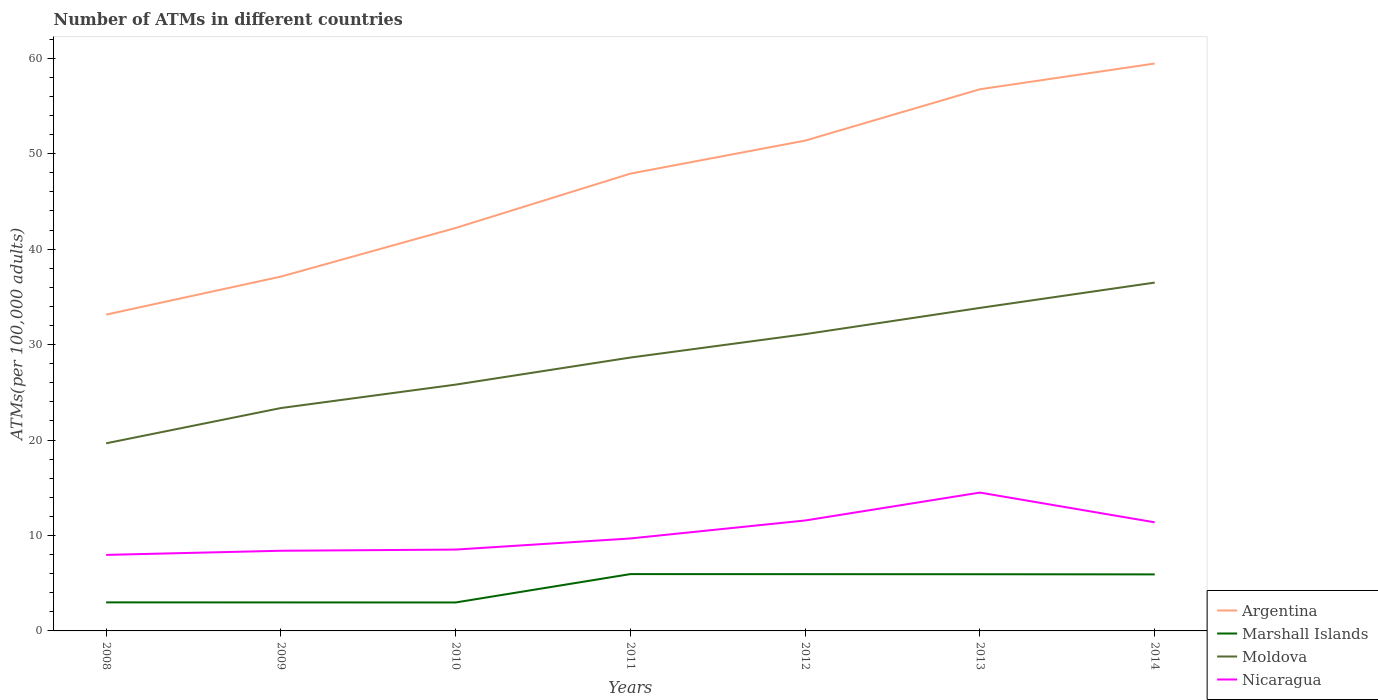How many different coloured lines are there?
Offer a terse response. 4. Is the number of lines equal to the number of legend labels?
Your answer should be compact. Yes. Across all years, what is the maximum number of ATMs in Marshall Islands?
Offer a very short reply. 2.98. What is the total number of ATMs in Marshall Islands in the graph?
Give a very brief answer. 0.02. What is the difference between the highest and the second highest number of ATMs in Moldova?
Your response must be concise. 16.84. Is the number of ATMs in Marshall Islands strictly greater than the number of ATMs in Nicaragua over the years?
Your answer should be very brief. Yes. How many years are there in the graph?
Provide a short and direct response. 7. Does the graph contain any zero values?
Ensure brevity in your answer.  No. Where does the legend appear in the graph?
Your answer should be very brief. Bottom right. What is the title of the graph?
Offer a terse response. Number of ATMs in different countries. What is the label or title of the X-axis?
Ensure brevity in your answer.  Years. What is the label or title of the Y-axis?
Offer a terse response. ATMs(per 100,0 adults). What is the ATMs(per 100,000 adults) in Argentina in 2008?
Provide a succinct answer. 33.14. What is the ATMs(per 100,000 adults) in Marshall Islands in 2008?
Your answer should be compact. 2.99. What is the ATMs(per 100,000 adults) in Moldova in 2008?
Offer a very short reply. 19.66. What is the ATMs(per 100,000 adults) of Nicaragua in 2008?
Your response must be concise. 7.97. What is the ATMs(per 100,000 adults) in Argentina in 2009?
Provide a short and direct response. 37.12. What is the ATMs(per 100,000 adults) in Marshall Islands in 2009?
Your answer should be compact. 2.99. What is the ATMs(per 100,000 adults) of Moldova in 2009?
Provide a short and direct response. 23.35. What is the ATMs(per 100,000 adults) in Nicaragua in 2009?
Keep it short and to the point. 8.4. What is the ATMs(per 100,000 adults) of Argentina in 2010?
Provide a succinct answer. 42.22. What is the ATMs(per 100,000 adults) of Marshall Islands in 2010?
Give a very brief answer. 2.98. What is the ATMs(per 100,000 adults) in Moldova in 2010?
Your answer should be compact. 25.81. What is the ATMs(per 100,000 adults) in Nicaragua in 2010?
Your response must be concise. 8.52. What is the ATMs(per 100,000 adults) in Argentina in 2011?
Ensure brevity in your answer.  47.91. What is the ATMs(per 100,000 adults) in Marshall Islands in 2011?
Ensure brevity in your answer.  5.95. What is the ATMs(per 100,000 adults) of Moldova in 2011?
Offer a very short reply. 28.64. What is the ATMs(per 100,000 adults) in Nicaragua in 2011?
Offer a terse response. 9.69. What is the ATMs(per 100,000 adults) of Argentina in 2012?
Your response must be concise. 51.37. What is the ATMs(per 100,000 adults) in Marshall Islands in 2012?
Keep it short and to the point. 5.95. What is the ATMs(per 100,000 adults) in Moldova in 2012?
Provide a succinct answer. 31.1. What is the ATMs(per 100,000 adults) in Nicaragua in 2012?
Make the answer very short. 11.57. What is the ATMs(per 100,000 adults) of Argentina in 2013?
Your answer should be compact. 56.75. What is the ATMs(per 100,000 adults) of Marshall Islands in 2013?
Make the answer very short. 5.94. What is the ATMs(per 100,000 adults) in Moldova in 2013?
Ensure brevity in your answer.  33.84. What is the ATMs(per 100,000 adults) in Nicaragua in 2013?
Your answer should be very brief. 14.5. What is the ATMs(per 100,000 adults) of Argentina in 2014?
Your answer should be very brief. 59.45. What is the ATMs(per 100,000 adults) in Marshall Islands in 2014?
Your answer should be compact. 5.92. What is the ATMs(per 100,000 adults) in Moldova in 2014?
Your answer should be very brief. 36.5. What is the ATMs(per 100,000 adults) of Nicaragua in 2014?
Offer a very short reply. 11.38. Across all years, what is the maximum ATMs(per 100,000 adults) of Argentina?
Provide a short and direct response. 59.45. Across all years, what is the maximum ATMs(per 100,000 adults) of Marshall Islands?
Your answer should be compact. 5.95. Across all years, what is the maximum ATMs(per 100,000 adults) in Moldova?
Make the answer very short. 36.5. Across all years, what is the maximum ATMs(per 100,000 adults) of Nicaragua?
Offer a terse response. 14.5. Across all years, what is the minimum ATMs(per 100,000 adults) in Argentina?
Offer a very short reply. 33.14. Across all years, what is the minimum ATMs(per 100,000 adults) in Marshall Islands?
Your response must be concise. 2.98. Across all years, what is the minimum ATMs(per 100,000 adults) of Moldova?
Keep it short and to the point. 19.66. Across all years, what is the minimum ATMs(per 100,000 adults) in Nicaragua?
Your response must be concise. 7.97. What is the total ATMs(per 100,000 adults) of Argentina in the graph?
Give a very brief answer. 327.98. What is the total ATMs(per 100,000 adults) in Marshall Islands in the graph?
Ensure brevity in your answer.  32.72. What is the total ATMs(per 100,000 adults) in Moldova in the graph?
Offer a terse response. 198.9. What is the total ATMs(per 100,000 adults) of Nicaragua in the graph?
Your response must be concise. 72.02. What is the difference between the ATMs(per 100,000 adults) of Argentina in 2008 and that in 2009?
Make the answer very short. -3.98. What is the difference between the ATMs(per 100,000 adults) of Marshall Islands in 2008 and that in 2009?
Provide a short and direct response. 0.01. What is the difference between the ATMs(per 100,000 adults) in Moldova in 2008 and that in 2009?
Give a very brief answer. -3.69. What is the difference between the ATMs(per 100,000 adults) of Nicaragua in 2008 and that in 2009?
Offer a very short reply. -0.43. What is the difference between the ATMs(per 100,000 adults) of Argentina in 2008 and that in 2010?
Your answer should be very brief. -9.08. What is the difference between the ATMs(per 100,000 adults) in Marshall Islands in 2008 and that in 2010?
Make the answer very short. 0.01. What is the difference between the ATMs(per 100,000 adults) of Moldova in 2008 and that in 2010?
Offer a terse response. -6.15. What is the difference between the ATMs(per 100,000 adults) in Nicaragua in 2008 and that in 2010?
Provide a short and direct response. -0.56. What is the difference between the ATMs(per 100,000 adults) in Argentina in 2008 and that in 2011?
Provide a short and direct response. -14.77. What is the difference between the ATMs(per 100,000 adults) of Marshall Islands in 2008 and that in 2011?
Provide a short and direct response. -2.96. What is the difference between the ATMs(per 100,000 adults) in Moldova in 2008 and that in 2011?
Provide a succinct answer. -8.99. What is the difference between the ATMs(per 100,000 adults) in Nicaragua in 2008 and that in 2011?
Keep it short and to the point. -1.72. What is the difference between the ATMs(per 100,000 adults) of Argentina in 2008 and that in 2012?
Your answer should be very brief. -18.23. What is the difference between the ATMs(per 100,000 adults) of Marshall Islands in 2008 and that in 2012?
Ensure brevity in your answer.  -2.96. What is the difference between the ATMs(per 100,000 adults) of Moldova in 2008 and that in 2012?
Offer a terse response. -11.44. What is the difference between the ATMs(per 100,000 adults) in Nicaragua in 2008 and that in 2012?
Give a very brief answer. -3.61. What is the difference between the ATMs(per 100,000 adults) in Argentina in 2008 and that in 2013?
Provide a succinct answer. -23.61. What is the difference between the ATMs(per 100,000 adults) of Marshall Islands in 2008 and that in 2013?
Offer a terse response. -2.95. What is the difference between the ATMs(per 100,000 adults) in Moldova in 2008 and that in 2013?
Provide a succinct answer. -14.19. What is the difference between the ATMs(per 100,000 adults) in Nicaragua in 2008 and that in 2013?
Offer a terse response. -6.53. What is the difference between the ATMs(per 100,000 adults) of Argentina in 2008 and that in 2014?
Offer a very short reply. -26.31. What is the difference between the ATMs(per 100,000 adults) in Marshall Islands in 2008 and that in 2014?
Make the answer very short. -2.93. What is the difference between the ATMs(per 100,000 adults) in Moldova in 2008 and that in 2014?
Make the answer very short. -16.84. What is the difference between the ATMs(per 100,000 adults) of Nicaragua in 2008 and that in 2014?
Give a very brief answer. -3.41. What is the difference between the ATMs(per 100,000 adults) of Argentina in 2009 and that in 2010?
Provide a short and direct response. -5.1. What is the difference between the ATMs(per 100,000 adults) of Marshall Islands in 2009 and that in 2010?
Keep it short and to the point. 0.01. What is the difference between the ATMs(per 100,000 adults) of Moldova in 2009 and that in 2010?
Give a very brief answer. -2.45. What is the difference between the ATMs(per 100,000 adults) of Nicaragua in 2009 and that in 2010?
Offer a terse response. -0.12. What is the difference between the ATMs(per 100,000 adults) in Argentina in 2009 and that in 2011?
Offer a terse response. -10.79. What is the difference between the ATMs(per 100,000 adults) in Marshall Islands in 2009 and that in 2011?
Ensure brevity in your answer.  -2.97. What is the difference between the ATMs(per 100,000 adults) in Moldova in 2009 and that in 2011?
Provide a short and direct response. -5.29. What is the difference between the ATMs(per 100,000 adults) of Nicaragua in 2009 and that in 2011?
Your response must be concise. -1.29. What is the difference between the ATMs(per 100,000 adults) in Argentina in 2009 and that in 2012?
Make the answer very short. -14.25. What is the difference between the ATMs(per 100,000 adults) of Marshall Islands in 2009 and that in 2012?
Your response must be concise. -2.96. What is the difference between the ATMs(per 100,000 adults) in Moldova in 2009 and that in 2012?
Give a very brief answer. -7.74. What is the difference between the ATMs(per 100,000 adults) of Nicaragua in 2009 and that in 2012?
Provide a succinct answer. -3.17. What is the difference between the ATMs(per 100,000 adults) of Argentina in 2009 and that in 2013?
Your answer should be compact. -19.63. What is the difference between the ATMs(per 100,000 adults) in Marshall Islands in 2009 and that in 2013?
Keep it short and to the point. -2.95. What is the difference between the ATMs(per 100,000 adults) of Moldova in 2009 and that in 2013?
Your response must be concise. -10.49. What is the difference between the ATMs(per 100,000 adults) in Nicaragua in 2009 and that in 2013?
Make the answer very short. -6.09. What is the difference between the ATMs(per 100,000 adults) of Argentina in 2009 and that in 2014?
Give a very brief answer. -22.33. What is the difference between the ATMs(per 100,000 adults) of Marshall Islands in 2009 and that in 2014?
Your answer should be very brief. -2.94. What is the difference between the ATMs(per 100,000 adults) of Moldova in 2009 and that in 2014?
Offer a very short reply. -13.15. What is the difference between the ATMs(per 100,000 adults) of Nicaragua in 2009 and that in 2014?
Keep it short and to the point. -2.98. What is the difference between the ATMs(per 100,000 adults) in Argentina in 2010 and that in 2011?
Offer a terse response. -5.69. What is the difference between the ATMs(per 100,000 adults) in Marshall Islands in 2010 and that in 2011?
Provide a succinct answer. -2.97. What is the difference between the ATMs(per 100,000 adults) of Moldova in 2010 and that in 2011?
Ensure brevity in your answer.  -2.84. What is the difference between the ATMs(per 100,000 adults) in Nicaragua in 2010 and that in 2011?
Provide a succinct answer. -1.16. What is the difference between the ATMs(per 100,000 adults) in Argentina in 2010 and that in 2012?
Your answer should be very brief. -9.15. What is the difference between the ATMs(per 100,000 adults) in Marshall Islands in 2010 and that in 2012?
Ensure brevity in your answer.  -2.97. What is the difference between the ATMs(per 100,000 adults) in Moldova in 2010 and that in 2012?
Offer a terse response. -5.29. What is the difference between the ATMs(per 100,000 adults) of Nicaragua in 2010 and that in 2012?
Offer a very short reply. -3.05. What is the difference between the ATMs(per 100,000 adults) of Argentina in 2010 and that in 2013?
Make the answer very short. -14.53. What is the difference between the ATMs(per 100,000 adults) in Marshall Islands in 2010 and that in 2013?
Your response must be concise. -2.96. What is the difference between the ATMs(per 100,000 adults) in Moldova in 2010 and that in 2013?
Keep it short and to the point. -8.04. What is the difference between the ATMs(per 100,000 adults) in Nicaragua in 2010 and that in 2013?
Your answer should be compact. -5.97. What is the difference between the ATMs(per 100,000 adults) of Argentina in 2010 and that in 2014?
Offer a very short reply. -17.23. What is the difference between the ATMs(per 100,000 adults) of Marshall Islands in 2010 and that in 2014?
Give a very brief answer. -2.94. What is the difference between the ATMs(per 100,000 adults) of Moldova in 2010 and that in 2014?
Ensure brevity in your answer.  -10.69. What is the difference between the ATMs(per 100,000 adults) of Nicaragua in 2010 and that in 2014?
Provide a succinct answer. -2.86. What is the difference between the ATMs(per 100,000 adults) of Argentina in 2011 and that in 2012?
Your answer should be compact. -3.46. What is the difference between the ATMs(per 100,000 adults) in Marshall Islands in 2011 and that in 2012?
Provide a succinct answer. 0.01. What is the difference between the ATMs(per 100,000 adults) in Moldova in 2011 and that in 2012?
Ensure brevity in your answer.  -2.45. What is the difference between the ATMs(per 100,000 adults) in Nicaragua in 2011 and that in 2012?
Provide a succinct answer. -1.88. What is the difference between the ATMs(per 100,000 adults) in Argentina in 2011 and that in 2013?
Your answer should be very brief. -8.84. What is the difference between the ATMs(per 100,000 adults) in Marshall Islands in 2011 and that in 2013?
Your response must be concise. 0.02. What is the difference between the ATMs(per 100,000 adults) in Moldova in 2011 and that in 2013?
Give a very brief answer. -5.2. What is the difference between the ATMs(per 100,000 adults) in Nicaragua in 2011 and that in 2013?
Ensure brevity in your answer.  -4.81. What is the difference between the ATMs(per 100,000 adults) in Argentina in 2011 and that in 2014?
Your answer should be compact. -11.54. What is the difference between the ATMs(per 100,000 adults) in Marshall Islands in 2011 and that in 2014?
Offer a terse response. 0.03. What is the difference between the ATMs(per 100,000 adults) of Moldova in 2011 and that in 2014?
Make the answer very short. -7.85. What is the difference between the ATMs(per 100,000 adults) in Nicaragua in 2011 and that in 2014?
Provide a succinct answer. -1.69. What is the difference between the ATMs(per 100,000 adults) of Argentina in 2012 and that in 2013?
Your response must be concise. -5.38. What is the difference between the ATMs(per 100,000 adults) in Marshall Islands in 2012 and that in 2013?
Make the answer very short. 0.01. What is the difference between the ATMs(per 100,000 adults) in Moldova in 2012 and that in 2013?
Provide a succinct answer. -2.75. What is the difference between the ATMs(per 100,000 adults) in Nicaragua in 2012 and that in 2013?
Your answer should be very brief. -2.92. What is the difference between the ATMs(per 100,000 adults) of Argentina in 2012 and that in 2014?
Offer a terse response. -8.08. What is the difference between the ATMs(per 100,000 adults) of Marshall Islands in 2012 and that in 2014?
Your answer should be compact. 0.02. What is the difference between the ATMs(per 100,000 adults) in Moldova in 2012 and that in 2014?
Your answer should be very brief. -5.4. What is the difference between the ATMs(per 100,000 adults) of Nicaragua in 2012 and that in 2014?
Give a very brief answer. 0.19. What is the difference between the ATMs(per 100,000 adults) in Argentina in 2013 and that in 2014?
Your answer should be compact. -2.7. What is the difference between the ATMs(per 100,000 adults) in Marshall Islands in 2013 and that in 2014?
Give a very brief answer. 0.02. What is the difference between the ATMs(per 100,000 adults) in Moldova in 2013 and that in 2014?
Your response must be concise. -2.65. What is the difference between the ATMs(per 100,000 adults) of Nicaragua in 2013 and that in 2014?
Provide a succinct answer. 3.12. What is the difference between the ATMs(per 100,000 adults) in Argentina in 2008 and the ATMs(per 100,000 adults) in Marshall Islands in 2009?
Ensure brevity in your answer.  30.16. What is the difference between the ATMs(per 100,000 adults) of Argentina in 2008 and the ATMs(per 100,000 adults) of Moldova in 2009?
Provide a succinct answer. 9.79. What is the difference between the ATMs(per 100,000 adults) of Argentina in 2008 and the ATMs(per 100,000 adults) of Nicaragua in 2009?
Keep it short and to the point. 24.74. What is the difference between the ATMs(per 100,000 adults) in Marshall Islands in 2008 and the ATMs(per 100,000 adults) in Moldova in 2009?
Provide a short and direct response. -20.36. What is the difference between the ATMs(per 100,000 adults) of Marshall Islands in 2008 and the ATMs(per 100,000 adults) of Nicaragua in 2009?
Your answer should be compact. -5.41. What is the difference between the ATMs(per 100,000 adults) of Moldova in 2008 and the ATMs(per 100,000 adults) of Nicaragua in 2009?
Ensure brevity in your answer.  11.26. What is the difference between the ATMs(per 100,000 adults) of Argentina in 2008 and the ATMs(per 100,000 adults) of Marshall Islands in 2010?
Keep it short and to the point. 30.16. What is the difference between the ATMs(per 100,000 adults) of Argentina in 2008 and the ATMs(per 100,000 adults) of Moldova in 2010?
Make the answer very short. 7.33. What is the difference between the ATMs(per 100,000 adults) of Argentina in 2008 and the ATMs(per 100,000 adults) of Nicaragua in 2010?
Offer a terse response. 24.62. What is the difference between the ATMs(per 100,000 adults) in Marshall Islands in 2008 and the ATMs(per 100,000 adults) in Moldova in 2010?
Provide a succinct answer. -22.81. What is the difference between the ATMs(per 100,000 adults) of Marshall Islands in 2008 and the ATMs(per 100,000 adults) of Nicaragua in 2010?
Make the answer very short. -5.53. What is the difference between the ATMs(per 100,000 adults) of Moldova in 2008 and the ATMs(per 100,000 adults) of Nicaragua in 2010?
Ensure brevity in your answer.  11.13. What is the difference between the ATMs(per 100,000 adults) in Argentina in 2008 and the ATMs(per 100,000 adults) in Marshall Islands in 2011?
Your response must be concise. 27.19. What is the difference between the ATMs(per 100,000 adults) in Argentina in 2008 and the ATMs(per 100,000 adults) in Moldova in 2011?
Offer a very short reply. 4.5. What is the difference between the ATMs(per 100,000 adults) in Argentina in 2008 and the ATMs(per 100,000 adults) in Nicaragua in 2011?
Your response must be concise. 23.45. What is the difference between the ATMs(per 100,000 adults) in Marshall Islands in 2008 and the ATMs(per 100,000 adults) in Moldova in 2011?
Offer a terse response. -25.65. What is the difference between the ATMs(per 100,000 adults) in Marshall Islands in 2008 and the ATMs(per 100,000 adults) in Nicaragua in 2011?
Ensure brevity in your answer.  -6.7. What is the difference between the ATMs(per 100,000 adults) in Moldova in 2008 and the ATMs(per 100,000 adults) in Nicaragua in 2011?
Keep it short and to the point. 9.97. What is the difference between the ATMs(per 100,000 adults) of Argentina in 2008 and the ATMs(per 100,000 adults) of Marshall Islands in 2012?
Ensure brevity in your answer.  27.19. What is the difference between the ATMs(per 100,000 adults) in Argentina in 2008 and the ATMs(per 100,000 adults) in Moldova in 2012?
Give a very brief answer. 2.05. What is the difference between the ATMs(per 100,000 adults) in Argentina in 2008 and the ATMs(per 100,000 adults) in Nicaragua in 2012?
Make the answer very short. 21.57. What is the difference between the ATMs(per 100,000 adults) of Marshall Islands in 2008 and the ATMs(per 100,000 adults) of Moldova in 2012?
Your response must be concise. -28.1. What is the difference between the ATMs(per 100,000 adults) in Marshall Islands in 2008 and the ATMs(per 100,000 adults) in Nicaragua in 2012?
Offer a terse response. -8.58. What is the difference between the ATMs(per 100,000 adults) in Moldova in 2008 and the ATMs(per 100,000 adults) in Nicaragua in 2012?
Provide a succinct answer. 8.09. What is the difference between the ATMs(per 100,000 adults) of Argentina in 2008 and the ATMs(per 100,000 adults) of Marshall Islands in 2013?
Your response must be concise. 27.2. What is the difference between the ATMs(per 100,000 adults) in Argentina in 2008 and the ATMs(per 100,000 adults) in Moldova in 2013?
Give a very brief answer. -0.7. What is the difference between the ATMs(per 100,000 adults) of Argentina in 2008 and the ATMs(per 100,000 adults) of Nicaragua in 2013?
Your answer should be compact. 18.65. What is the difference between the ATMs(per 100,000 adults) in Marshall Islands in 2008 and the ATMs(per 100,000 adults) in Moldova in 2013?
Your answer should be compact. -30.85. What is the difference between the ATMs(per 100,000 adults) of Marshall Islands in 2008 and the ATMs(per 100,000 adults) of Nicaragua in 2013?
Provide a short and direct response. -11.5. What is the difference between the ATMs(per 100,000 adults) in Moldova in 2008 and the ATMs(per 100,000 adults) in Nicaragua in 2013?
Your answer should be very brief. 5.16. What is the difference between the ATMs(per 100,000 adults) of Argentina in 2008 and the ATMs(per 100,000 adults) of Marshall Islands in 2014?
Ensure brevity in your answer.  27.22. What is the difference between the ATMs(per 100,000 adults) of Argentina in 2008 and the ATMs(per 100,000 adults) of Moldova in 2014?
Your answer should be compact. -3.36. What is the difference between the ATMs(per 100,000 adults) of Argentina in 2008 and the ATMs(per 100,000 adults) of Nicaragua in 2014?
Ensure brevity in your answer.  21.76. What is the difference between the ATMs(per 100,000 adults) of Marshall Islands in 2008 and the ATMs(per 100,000 adults) of Moldova in 2014?
Keep it short and to the point. -33.51. What is the difference between the ATMs(per 100,000 adults) in Marshall Islands in 2008 and the ATMs(per 100,000 adults) in Nicaragua in 2014?
Your answer should be compact. -8.39. What is the difference between the ATMs(per 100,000 adults) of Moldova in 2008 and the ATMs(per 100,000 adults) of Nicaragua in 2014?
Give a very brief answer. 8.28. What is the difference between the ATMs(per 100,000 adults) in Argentina in 2009 and the ATMs(per 100,000 adults) in Marshall Islands in 2010?
Offer a very short reply. 34.14. What is the difference between the ATMs(per 100,000 adults) in Argentina in 2009 and the ATMs(per 100,000 adults) in Moldova in 2010?
Keep it short and to the point. 11.32. What is the difference between the ATMs(per 100,000 adults) of Argentina in 2009 and the ATMs(per 100,000 adults) of Nicaragua in 2010?
Make the answer very short. 28.6. What is the difference between the ATMs(per 100,000 adults) of Marshall Islands in 2009 and the ATMs(per 100,000 adults) of Moldova in 2010?
Make the answer very short. -22.82. What is the difference between the ATMs(per 100,000 adults) of Marshall Islands in 2009 and the ATMs(per 100,000 adults) of Nicaragua in 2010?
Your answer should be compact. -5.54. What is the difference between the ATMs(per 100,000 adults) of Moldova in 2009 and the ATMs(per 100,000 adults) of Nicaragua in 2010?
Provide a succinct answer. 14.83. What is the difference between the ATMs(per 100,000 adults) of Argentina in 2009 and the ATMs(per 100,000 adults) of Marshall Islands in 2011?
Your answer should be compact. 31.17. What is the difference between the ATMs(per 100,000 adults) in Argentina in 2009 and the ATMs(per 100,000 adults) in Moldova in 2011?
Keep it short and to the point. 8.48. What is the difference between the ATMs(per 100,000 adults) of Argentina in 2009 and the ATMs(per 100,000 adults) of Nicaragua in 2011?
Provide a succinct answer. 27.44. What is the difference between the ATMs(per 100,000 adults) in Marshall Islands in 2009 and the ATMs(per 100,000 adults) in Moldova in 2011?
Your answer should be very brief. -25.66. What is the difference between the ATMs(per 100,000 adults) of Marshall Islands in 2009 and the ATMs(per 100,000 adults) of Nicaragua in 2011?
Offer a terse response. -6.7. What is the difference between the ATMs(per 100,000 adults) in Moldova in 2009 and the ATMs(per 100,000 adults) in Nicaragua in 2011?
Give a very brief answer. 13.67. What is the difference between the ATMs(per 100,000 adults) in Argentina in 2009 and the ATMs(per 100,000 adults) in Marshall Islands in 2012?
Give a very brief answer. 31.18. What is the difference between the ATMs(per 100,000 adults) in Argentina in 2009 and the ATMs(per 100,000 adults) in Moldova in 2012?
Offer a terse response. 6.03. What is the difference between the ATMs(per 100,000 adults) of Argentina in 2009 and the ATMs(per 100,000 adults) of Nicaragua in 2012?
Keep it short and to the point. 25.55. What is the difference between the ATMs(per 100,000 adults) in Marshall Islands in 2009 and the ATMs(per 100,000 adults) in Moldova in 2012?
Offer a terse response. -28.11. What is the difference between the ATMs(per 100,000 adults) of Marshall Islands in 2009 and the ATMs(per 100,000 adults) of Nicaragua in 2012?
Ensure brevity in your answer.  -8.59. What is the difference between the ATMs(per 100,000 adults) in Moldova in 2009 and the ATMs(per 100,000 adults) in Nicaragua in 2012?
Offer a terse response. 11.78. What is the difference between the ATMs(per 100,000 adults) of Argentina in 2009 and the ATMs(per 100,000 adults) of Marshall Islands in 2013?
Provide a short and direct response. 31.19. What is the difference between the ATMs(per 100,000 adults) of Argentina in 2009 and the ATMs(per 100,000 adults) of Moldova in 2013?
Your answer should be compact. 3.28. What is the difference between the ATMs(per 100,000 adults) of Argentina in 2009 and the ATMs(per 100,000 adults) of Nicaragua in 2013?
Your response must be concise. 22.63. What is the difference between the ATMs(per 100,000 adults) in Marshall Islands in 2009 and the ATMs(per 100,000 adults) in Moldova in 2013?
Offer a very short reply. -30.86. What is the difference between the ATMs(per 100,000 adults) of Marshall Islands in 2009 and the ATMs(per 100,000 adults) of Nicaragua in 2013?
Keep it short and to the point. -11.51. What is the difference between the ATMs(per 100,000 adults) in Moldova in 2009 and the ATMs(per 100,000 adults) in Nicaragua in 2013?
Your response must be concise. 8.86. What is the difference between the ATMs(per 100,000 adults) of Argentina in 2009 and the ATMs(per 100,000 adults) of Marshall Islands in 2014?
Your answer should be compact. 31.2. What is the difference between the ATMs(per 100,000 adults) of Argentina in 2009 and the ATMs(per 100,000 adults) of Moldova in 2014?
Give a very brief answer. 0.63. What is the difference between the ATMs(per 100,000 adults) of Argentina in 2009 and the ATMs(per 100,000 adults) of Nicaragua in 2014?
Give a very brief answer. 25.75. What is the difference between the ATMs(per 100,000 adults) of Marshall Islands in 2009 and the ATMs(per 100,000 adults) of Moldova in 2014?
Your answer should be compact. -33.51. What is the difference between the ATMs(per 100,000 adults) in Marshall Islands in 2009 and the ATMs(per 100,000 adults) in Nicaragua in 2014?
Your answer should be compact. -8.39. What is the difference between the ATMs(per 100,000 adults) of Moldova in 2009 and the ATMs(per 100,000 adults) of Nicaragua in 2014?
Give a very brief answer. 11.97. What is the difference between the ATMs(per 100,000 adults) of Argentina in 2010 and the ATMs(per 100,000 adults) of Marshall Islands in 2011?
Ensure brevity in your answer.  36.27. What is the difference between the ATMs(per 100,000 adults) of Argentina in 2010 and the ATMs(per 100,000 adults) of Moldova in 2011?
Your answer should be very brief. 13.58. What is the difference between the ATMs(per 100,000 adults) in Argentina in 2010 and the ATMs(per 100,000 adults) in Nicaragua in 2011?
Make the answer very short. 32.53. What is the difference between the ATMs(per 100,000 adults) in Marshall Islands in 2010 and the ATMs(per 100,000 adults) in Moldova in 2011?
Your answer should be compact. -25.66. What is the difference between the ATMs(per 100,000 adults) of Marshall Islands in 2010 and the ATMs(per 100,000 adults) of Nicaragua in 2011?
Your answer should be compact. -6.71. What is the difference between the ATMs(per 100,000 adults) in Moldova in 2010 and the ATMs(per 100,000 adults) in Nicaragua in 2011?
Your answer should be compact. 16.12. What is the difference between the ATMs(per 100,000 adults) of Argentina in 2010 and the ATMs(per 100,000 adults) of Marshall Islands in 2012?
Give a very brief answer. 36.27. What is the difference between the ATMs(per 100,000 adults) in Argentina in 2010 and the ATMs(per 100,000 adults) in Moldova in 2012?
Make the answer very short. 11.13. What is the difference between the ATMs(per 100,000 adults) in Argentina in 2010 and the ATMs(per 100,000 adults) in Nicaragua in 2012?
Ensure brevity in your answer.  30.65. What is the difference between the ATMs(per 100,000 adults) in Marshall Islands in 2010 and the ATMs(per 100,000 adults) in Moldova in 2012?
Make the answer very short. -28.11. What is the difference between the ATMs(per 100,000 adults) in Marshall Islands in 2010 and the ATMs(per 100,000 adults) in Nicaragua in 2012?
Your answer should be compact. -8.59. What is the difference between the ATMs(per 100,000 adults) of Moldova in 2010 and the ATMs(per 100,000 adults) of Nicaragua in 2012?
Your answer should be compact. 14.23. What is the difference between the ATMs(per 100,000 adults) of Argentina in 2010 and the ATMs(per 100,000 adults) of Marshall Islands in 2013?
Offer a terse response. 36.28. What is the difference between the ATMs(per 100,000 adults) in Argentina in 2010 and the ATMs(per 100,000 adults) in Moldova in 2013?
Ensure brevity in your answer.  8.38. What is the difference between the ATMs(per 100,000 adults) of Argentina in 2010 and the ATMs(per 100,000 adults) of Nicaragua in 2013?
Your answer should be very brief. 27.73. What is the difference between the ATMs(per 100,000 adults) in Marshall Islands in 2010 and the ATMs(per 100,000 adults) in Moldova in 2013?
Provide a succinct answer. -30.86. What is the difference between the ATMs(per 100,000 adults) of Marshall Islands in 2010 and the ATMs(per 100,000 adults) of Nicaragua in 2013?
Your response must be concise. -11.51. What is the difference between the ATMs(per 100,000 adults) of Moldova in 2010 and the ATMs(per 100,000 adults) of Nicaragua in 2013?
Make the answer very short. 11.31. What is the difference between the ATMs(per 100,000 adults) of Argentina in 2010 and the ATMs(per 100,000 adults) of Marshall Islands in 2014?
Offer a terse response. 36.3. What is the difference between the ATMs(per 100,000 adults) of Argentina in 2010 and the ATMs(per 100,000 adults) of Moldova in 2014?
Keep it short and to the point. 5.72. What is the difference between the ATMs(per 100,000 adults) in Argentina in 2010 and the ATMs(per 100,000 adults) in Nicaragua in 2014?
Provide a short and direct response. 30.84. What is the difference between the ATMs(per 100,000 adults) in Marshall Islands in 2010 and the ATMs(per 100,000 adults) in Moldova in 2014?
Your answer should be compact. -33.52. What is the difference between the ATMs(per 100,000 adults) of Marshall Islands in 2010 and the ATMs(per 100,000 adults) of Nicaragua in 2014?
Provide a short and direct response. -8.4. What is the difference between the ATMs(per 100,000 adults) of Moldova in 2010 and the ATMs(per 100,000 adults) of Nicaragua in 2014?
Provide a succinct answer. 14.43. What is the difference between the ATMs(per 100,000 adults) in Argentina in 2011 and the ATMs(per 100,000 adults) in Marshall Islands in 2012?
Provide a succinct answer. 41.97. What is the difference between the ATMs(per 100,000 adults) of Argentina in 2011 and the ATMs(per 100,000 adults) of Moldova in 2012?
Offer a very short reply. 16.82. What is the difference between the ATMs(per 100,000 adults) of Argentina in 2011 and the ATMs(per 100,000 adults) of Nicaragua in 2012?
Make the answer very short. 36.34. What is the difference between the ATMs(per 100,000 adults) of Marshall Islands in 2011 and the ATMs(per 100,000 adults) of Moldova in 2012?
Offer a terse response. -25.14. What is the difference between the ATMs(per 100,000 adults) of Marshall Islands in 2011 and the ATMs(per 100,000 adults) of Nicaragua in 2012?
Make the answer very short. -5.62. What is the difference between the ATMs(per 100,000 adults) of Moldova in 2011 and the ATMs(per 100,000 adults) of Nicaragua in 2012?
Offer a very short reply. 17.07. What is the difference between the ATMs(per 100,000 adults) in Argentina in 2011 and the ATMs(per 100,000 adults) in Marshall Islands in 2013?
Provide a short and direct response. 41.98. What is the difference between the ATMs(per 100,000 adults) in Argentina in 2011 and the ATMs(per 100,000 adults) in Moldova in 2013?
Your answer should be very brief. 14.07. What is the difference between the ATMs(per 100,000 adults) in Argentina in 2011 and the ATMs(per 100,000 adults) in Nicaragua in 2013?
Make the answer very short. 33.42. What is the difference between the ATMs(per 100,000 adults) in Marshall Islands in 2011 and the ATMs(per 100,000 adults) in Moldova in 2013?
Your answer should be compact. -27.89. What is the difference between the ATMs(per 100,000 adults) in Marshall Islands in 2011 and the ATMs(per 100,000 adults) in Nicaragua in 2013?
Ensure brevity in your answer.  -8.54. What is the difference between the ATMs(per 100,000 adults) of Moldova in 2011 and the ATMs(per 100,000 adults) of Nicaragua in 2013?
Your answer should be compact. 14.15. What is the difference between the ATMs(per 100,000 adults) in Argentina in 2011 and the ATMs(per 100,000 adults) in Marshall Islands in 2014?
Provide a succinct answer. 41.99. What is the difference between the ATMs(per 100,000 adults) of Argentina in 2011 and the ATMs(per 100,000 adults) of Moldova in 2014?
Your answer should be very brief. 11.42. What is the difference between the ATMs(per 100,000 adults) in Argentina in 2011 and the ATMs(per 100,000 adults) in Nicaragua in 2014?
Offer a very short reply. 36.53. What is the difference between the ATMs(per 100,000 adults) in Marshall Islands in 2011 and the ATMs(per 100,000 adults) in Moldova in 2014?
Give a very brief answer. -30.54. What is the difference between the ATMs(per 100,000 adults) in Marshall Islands in 2011 and the ATMs(per 100,000 adults) in Nicaragua in 2014?
Your response must be concise. -5.42. What is the difference between the ATMs(per 100,000 adults) in Moldova in 2011 and the ATMs(per 100,000 adults) in Nicaragua in 2014?
Keep it short and to the point. 17.26. What is the difference between the ATMs(per 100,000 adults) of Argentina in 2012 and the ATMs(per 100,000 adults) of Marshall Islands in 2013?
Keep it short and to the point. 45.43. What is the difference between the ATMs(per 100,000 adults) in Argentina in 2012 and the ATMs(per 100,000 adults) in Moldova in 2013?
Make the answer very short. 17.53. What is the difference between the ATMs(per 100,000 adults) of Argentina in 2012 and the ATMs(per 100,000 adults) of Nicaragua in 2013?
Provide a short and direct response. 36.88. What is the difference between the ATMs(per 100,000 adults) of Marshall Islands in 2012 and the ATMs(per 100,000 adults) of Moldova in 2013?
Keep it short and to the point. -27.9. What is the difference between the ATMs(per 100,000 adults) in Marshall Islands in 2012 and the ATMs(per 100,000 adults) in Nicaragua in 2013?
Give a very brief answer. -8.55. What is the difference between the ATMs(per 100,000 adults) of Moldova in 2012 and the ATMs(per 100,000 adults) of Nicaragua in 2013?
Provide a short and direct response. 16.6. What is the difference between the ATMs(per 100,000 adults) of Argentina in 2012 and the ATMs(per 100,000 adults) of Marshall Islands in 2014?
Ensure brevity in your answer.  45.45. What is the difference between the ATMs(per 100,000 adults) of Argentina in 2012 and the ATMs(per 100,000 adults) of Moldova in 2014?
Provide a succinct answer. 14.87. What is the difference between the ATMs(per 100,000 adults) in Argentina in 2012 and the ATMs(per 100,000 adults) in Nicaragua in 2014?
Your response must be concise. 39.99. What is the difference between the ATMs(per 100,000 adults) in Marshall Islands in 2012 and the ATMs(per 100,000 adults) in Moldova in 2014?
Make the answer very short. -30.55. What is the difference between the ATMs(per 100,000 adults) of Marshall Islands in 2012 and the ATMs(per 100,000 adults) of Nicaragua in 2014?
Make the answer very short. -5.43. What is the difference between the ATMs(per 100,000 adults) of Moldova in 2012 and the ATMs(per 100,000 adults) of Nicaragua in 2014?
Ensure brevity in your answer.  19.72. What is the difference between the ATMs(per 100,000 adults) in Argentina in 2013 and the ATMs(per 100,000 adults) in Marshall Islands in 2014?
Your answer should be very brief. 50.83. What is the difference between the ATMs(per 100,000 adults) of Argentina in 2013 and the ATMs(per 100,000 adults) of Moldova in 2014?
Your answer should be very brief. 20.26. What is the difference between the ATMs(per 100,000 adults) in Argentina in 2013 and the ATMs(per 100,000 adults) in Nicaragua in 2014?
Provide a succinct answer. 45.37. What is the difference between the ATMs(per 100,000 adults) in Marshall Islands in 2013 and the ATMs(per 100,000 adults) in Moldova in 2014?
Your answer should be compact. -30.56. What is the difference between the ATMs(per 100,000 adults) in Marshall Islands in 2013 and the ATMs(per 100,000 adults) in Nicaragua in 2014?
Keep it short and to the point. -5.44. What is the difference between the ATMs(per 100,000 adults) in Moldova in 2013 and the ATMs(per 100,000 adults) in Nicaragua in 2014?
Your answer should be very brief. 22.47. What is the average ATMs(per 100,000 adults) of Argentina per year?
Provide a succinct answer. 46.85. What is the average ATMs(per 100,000 adults) in Marshall Islands per year?
Offer a terse response. 4.67. What is the average ATMs(per 100,000 adults) of Moldova per year?
Your answer should be very brief. 28.41. What is the average ATMs(per 100,000 adults) in Nicaragua per year?
Provide a succinct answer. 10.29. In the year 2008, what is the difference between the ATMs(per 100,000 adults) in Argentina and ATMs(per 100,000 adults) in Marshall Islands?
Your answer should be compact. 30.15. In the year 2008, what is the difference between the ATMs(per 100,000 adults) of Argentina and ATMs(per 100,000 adults) of Moldova?
Give a very brief answer. 13.48. In the year 2008, what is the difference between the ATMs(per 100,000 adults) of Argentina and ATMs(per 100,000 adults) of Nicaragua?
Your answer should be compact. 25.18. In the year 2008, what is the difference between the ATMs(per 100,000 adults) in Marshall Islands and ATMs(per 100,000 adults) in Moldova?
Make the answer very short. -16.67. In the year 2008, what is the difference between the ATMs(per 100,000 adults) in Marshall Islands and ATMs(per 100,000 adults) in Nicaragua?
Offer a very short reply. -4.97. In the year 2008, what is the difference between the ATMs(per 100,000 adults) in Moldova and ATMs(per 100,000 adults) in Nicaragua?
Your response must be concise. 11.69. In the year 2009, what is the difference between the ATMs(per 100,000 adults) in Argentina and ATMs(per 100,000 adults) in Marshall Islands?
Provide a succinct answer. 34.14. In the year 2009, what is the difference between the ATMs(per 100,000 adults) of Argentina and ATMs(per 100,000 adults) of Moldova?
Keep it short and to the point. 13.77. In the year 2009, what is the difference between the ATMs(per 100,000 adults) in Argentina and ATMs(per 100,000 adults) in Nicaragua?
Provide a succinct answer. 28.72. In the year 2009, what is the difference between the ATMs(per 100,000 adults) in Marshall Islands and ATMs(per 100,000 adults) in Moldova?
Keep it short and to the point. -20.37. In the year 2009, what is the difference between the ATMs(per 100,000 adults) of Marshall Islands and ATMs(per 100,000 adults) of Nicaragua?
Offer a very short reply. -5.41. In the year 2009, what is the difference between the ATMs(per 100,000 adults) of Moldova and ATMs(per 100,000 adults) of Nicaragua?
Provide a short and direct response. 14.95. In the year 2010, what is the difference between the ATMs(per 100,000 adults) of Argentina and ATMs(per 100,000 adults) of Marshall Islands?
Ensure brevity in your answer.  39.24. In the year 2010, what is the difference between the ATMs(per 100,000 adults) in Argentina and ATMs(per 100,000 adults) in Moldova?
Your answer should be very brief. 16.41. In the year 2010, what is the difference between the ATMs(per 100,000 adults) in Argentina and ATMs(per 100,000 adults) in Nicaragua?
Keep it short and to the point. 33.7. In the year 2010, what is the difference between the ATMs(per 100,000 adults) of Marshall Islands and ATMs(per 100,000 adults) of Moldova?
Make the answer very short. -22.83. In the year 2010, what is the difference between the ATMs(per 100,000 adults) of Marshall Islands and ATMs(per 100,000 adults) of Nicaragua?
Keep it short and to the point. -5.54. In the year 2010, what is the difference between the ATMs(per 100,000 adults) of Moldova and ATMs(per 100,000 adults) of Nicaragua?
Provide a short and direct response. 17.28. In the year 2011, what is the difference between the ATMs(per 100,000 adults) of Argentina and ATMs(per 100,000 adults) of Marshall Islands?
Your response must be concise. 41.96. In the year 2011, what is the difference between the ATMs(per 100,000 adults) of Argentina and ATMs(per 100,000 adults) of Moldova?
Offer a terse response. 19.27. In the year 2011, what is the difference between the ATMs(per 100,000 adults) of Argentina and ATMs(per 100,000 adults) of Nicaragua?
Your answer should be compact. 38.23. In the year 2011, what is the difference between the ATMs(per 100,000 adults) in Marshall Islands and ATMs(per 100,000 adults) in Moldova?
Your answer should be compact. -22.69. In the year 2011, what is the difference between the ATMs(per 100,000 adults) in Marshall Islands and ATMs(per 100,000 adults) in Nicaragua?
Your answer should be compact. -3.73. In the year 2011, what is the difference between the ATMs(per 100,000 adults) in Moldova and ATMs(per 100,000 adults) in Nicaragua?
Offer a very short reply. 18.96. In the year 2012, what is the difference between the ATMs(per 100,000 adults) in Argentina and ATMs(per 100,000 adults) in Marshall Islands?
Provide a succinct answer. 45.42. In the year 2012, what is the difference between the ATMs(per 100,000 adults) of Argentina and ATMs(per 100,000 adults) of Moldova?
Provide a succinct answer. 20.28. In the year 2012, what is the difference between the ATMs(per 100,000 adults) of Argentina and ATMs(per 100,000 adults) of Nicaragua?
Ensure brevity in your answer.  39.8. In the year 2012, what is the difference between the ATMs(per 100,000 adults) of Marshall Islands and ATMs(per 100,000 adults) of Moldova?
Make the answer very short. -25.15. In the year 2012, what is the difference between the ATMs(per 100,000 adults) in Marshall Islands and ATMs(per 100,000 adults) in Nicaragua?
Ensure brevity in your answer.  -5.62. In the year 2012, what is the difference between the ATMs(per 100,000 adults) of Moldova and ATMs(per 100,000 adults) of Nicaragua?
Keep it short and to the point. 19.52. In the year 2013, what is the difference between the ATMs(per 100,000 adults) in Argentina and ATMs(per 100,000 adults) in Marshall Islands?
Offer a very short reply. 50.81. In the year 2013, what is the difference between the ATMs(per 100,000 adults) of Argentina and ATMs(per 100,000 adults) of Moldova?
Give a very brief answer. 22.91. In the year 2013, what is the difference between the ATMs(per 100,000 adults) in Argentina and ATMs(per 100,000 adults) in Nicaragua?
Your answer should be compact. 42.26. In the year 2013, what is the difference between the ATMs(per 100,000 adults) of Marshall Islands and ATMs(per 100,000 adults) of Moldova?
Make the answer very short. -27.91. In the year 2013, what is the difference between the ATMs(per 100,000 adults) in Marshall Islands and ATMs(per 100,000 adults) in Nicaragua?
Make the answer very short. -8.56. In the year 2013, what is the difference between the ATMs(per 100,000 adults) of Moldova and ATMs(per 100,000 adults) of Nicaragua?
Ensure brevity in your answer.  19.35. In the year 2014, what is the difference between the ATMs(per 100,000 adults) in Argentina and ATMs(per 100,000 adults) in Marshall Islands?
Your response must be concise. 53.53. In the year 2014, what is the difference between the ATMs(per 100,000 adults) of Argentina and ATMs(per 100,000 adults) of Moldova?
Provide a succinct answer. 22.95. In the year 2014, what is the difference between the ATMs(per 100,000 adults) of Argentina and ATMs(per 100,000 adults) of Nicaragua?
Offer a very short reply. 48.07. In the year 2014, what is the difference between the ATMs(per 100,000 adults) of Marshall Islands and ATMs(per 100,000 adults) of Moldova?
Your answer should be very brief. -30.57. In the year 2014, what is the difference between the ATMs(per 100,000 adults) of Marshall Islands and ATMs(per 100,000 adults) of Nicaragua?
Provide a short and direct response. -5.46. In the year 2014, what is the difference between the ATMs(per 100,000 adults) in Moldova and ATMs(per 100,000 adults) in Nicaragua?
Offer a very short reply. 25.12. What is the ratio of the ATMs(per 100,000 adults) of Argentina in 2008 to that in 2009?
Keep it short and to the point. 0.89. What is the ratio of the ATMs(per 100,000 adults) of Marshall Islands in 2008 to that in 2009?
Keep it short and to the point. 1. What is the ratio of the ATMs(per 100,000 adults) in Moldova in 2008 to that in 2009?
Offer a very short reply. 0.84. What is the ratio of the ATMs(per 100,000 adults) of Nicaragua in 2008 to that in 2009?
Offer a very short reply. 0.95. What is the ratio of the ATMs(per 100,000 adults) of Argentina in 2008 to that in 2010?
Offer a terse response. 0.78. What is the ratio of the ATMs(per 100,000 adults) of Marshall Islands in 2008 to that in 2010?
Ensure brevity in your answer.  1. What is the ratio of the ATMs(per 100,000 adults) of Moldova in 2008 to that in 2010?
Your answer should be compact. 0.76. What is the ratio of the ATMs(per 100,000 adults) of Nicaragua in 2008 to that in 2010?
Offer a very short reply. 0.93. What is the ratio of the ATMs(per 100,000 adults) in Argentina in 2008 to that in 2011?
Provide a short and direct response. 0.69. What is the ratio of the ATMs(per 100,000 adults) of Marshall Islands in 2008 to that in 2011?
Ensure brevity in your answer.  0.5. What is the ratio of the ATMs(per 100,000 adults) in Moldova in 2008 to that in 2011?
Provide a short and direct response. 0.69. What is the ratio of the ATMs(per 100,000 adults) of Nicaragua in 2008 to that in 2011?
Your response must be concise. 0.82. What is the ratio of the ATMs(per 100,000 adults) in Argentina in 2008 to that in 2012?
Provide a succinct answer. 0.65. What is the ratio of the ATMs(per 100,000 adults) in Marshall Islands in 2008 to that in 2012?
Provide a short and direct response. 0.5. What is the ratio of the ATMs(per 100,000 adults) in Moldova in 2008 to that in 2012?
Your response must be concise. 0.63. What is the ratio of the ATMs(per 100,000 adults) of Nicaragua in 2008 to that in 2012?
Offer a very short reply. 0.69. What is the ratio of the ATMs(per 100,000 adults) of Argentina in 2008 to that in 2013?
Give a very brief answer. 0.58. What is the ratio of the ATMs(per 100,000 adults) in Marshall Islands in 2008 to that in 2013?
Offer a terse response. 0.5. What is the ratio of the ATMs(per 100,000 adults) of Moldova in 2008 to that in 2013?
Your response must be concise. 0.58. What is the ratio of the ATMs(per 100,000 adults) in Nicaragua in 2008 to that in 2013?
Provide a short and direct response. 0.55. What is the ratio of the ATMs(per 100,000 adults) of Argentina in 2008 to that in 2014?
Keep it short and to the point. 0.56. What is the ratio of the ATMs(per 100,000 adults) of Marshall Islands in 2008 to that in 2014?
Offer a terse response. 0.51. What is the ratio of the ATMs(per 100,000 adults) in Moldova in 2008 to that in 2014?
Ensure brevity in your answer.  0.54. What is the ratio of the ATMs(per 100,000 adults) of Nicaragua in 2008 to that in 2014?
Make the answer very short. 0.7. What is the ratio of the ATMs(per 100,000 adults) in Argentina in 2009 to that in 2010?
Keep it short and to the point. 0.88. What is the ratio of the ATMs(per 100,000 adults) of Moldova in 2009 to that in 2010?
Your response must be concise. 0.9. What is the ratio of the ATMs(per 100,000 adults) of Nicaragua in 2009 to that in 2010?
Provide a short and direct response. 0.99. What is the ratio of the ATMs(per 100,000 adults) of Argentina in 2009 to that in 2011?
Your answer should be very brief. 0.77. What is the ratio of the ATMs(per 100,000 adults) of Marshall Islands in 2009 to that in 2011?
Offer a very short reply. 0.5. What is the ratio of the ATMs(per 100,000 adults) of Moldova in 2009 to that in 2011?
Offer a terse response. 0.82. What is the ratio of the ATMs(per 100,000 adults) of Nicaragua in 2009 to that in 2011?
Offer a very short reply. 0.87. What is the ratio of the ATMs(per 100,000 adults) of Argentina in 2009 to that in 2012?
Make the answer very short. 0.72. What is the ratio of the ATMs(per 100,000 adults) of Marshall Islands in 2009 to that in 2012?
Your answer should be very brief. 0.5. What is the ratio of the ATMs(per 100,000 adults) of Moldova in 2009 to that in 2012?
Ensure brevity in your answer.  0.75. What is the ratio of the ATMs(per 100,000 adults) of Nicaragua in 2009 to that in 2012?
Your answer should be very brief. 0.73. What is the ratio of the ATMs(per 100,000 adults) of Argentina in 2009 to that in 2013?
Make the answer very short. 0.65. What is the ratio of the ATMs(per 100,000 adults) of Marshall Islands in 2009 to that in 2013?
Offer a very short reply. 0.5. What is the ratio of the ATMs(per 100,000 adults) in Moldova in 2009 to that in 2013?
Ensure brevity in your answer.  0.69. What is the ratio of the ATMs(per 100,000 adults) of Nicaragua in 2009 to that in 2013?
Keep it short and to the point. 0.58. What is the ratio of the ATMs(per 100,000 adults) in Argentina in 2009 to that in 2014?
Your answer should be very brief. 0.62. What is the ratio of the ATMs(per 100,000 adults) in Marshall Islands in 2009 to that in 2014?
Provide a succinct answer. 0.5. What is the ratio of the ATMs(per 100,000 adults) of Moldova in 2009 to that in 2014?
Provide a succinct answer. 0.64. What is the ratio of the ATMs(per 100,000 adults) of Nicaragua in 2009 to that in 2014?
Ensure brevity in your answer.  0.74. What is the ratio of the ATMs(per 100,000 adults) of Argentina in 2010 to that in 2011?
Provide a succinct answer. 0.88. What is the ratio of the ATMs(per 100,000 adults) of Marshall Islands in 2010 to that in 2011?
Offer a terse response. 0.5. What is the ratio of the ATMs(per 100,000 adults) of Moldova in 2010 to that in 2011?
Your response must be concise. 0.9. What is the ratio of the ATMs(per 100,000 adults) in Nicaragua in 2010 to that in 2011?
Offer a terse response. 0.88. What is the ratio of the ATMs(per 100,000 adults) of Argentina in 2010 to that in 2012?
Offer a terse response. 0.82. What is the ratio of the ATMs(per 100,000 adults) in Marshall Islands in 2010 to that in 2012?
Ensure brevity in your answer.  0.5. What is the ratio of the ATMs(per 100,000 adults) in Moldova in 2010 to that in 2012?
Provide a short and direct response. 0.83. What is the ratio of the ATMs(per 100,000 adults) of Nicaragua in 2010 to that in 2012?
Offer a very short reply. 0.74. What is the ratio of the ATMs(per 100,000 adults) of Argentina in 2010 to that in 2013?
Provide a short and direct response. 0.74. What is the ratio of the ATMs(per 100,000 adults) in Marshall Islands in 2010 to that in 2013?
Ensure brevity in your answer.  0.5. What is the ratio of the ATMs(per 100,000 adults) in Moldova in 2010 to that in 2013?
Provide a short and direct response. 0.76. What is the ratio of the ATMs(per 100,000 adults) of Nicaragua in 2010 to that in 2013?
Give a very brief answer. 0.59. What is the ratio of the ATMs(per 100,000 adults) of Argentina in 2010 to that in 2014?
Ensure brevity in your answer.  0.71. What is the ratio of the ATMs(per 100,000 adults) of Marshall Islands in 2010 to that in 2014?
Keep it short and to the point. 0.5. What is the ratio of the ATMs(per 100,000 adults) of Moldova in 2010 to that in 2014?
Make the answer very short. 0.71. What is the ratio of the ATMs(per 100,000 adults) in Nicaragua in 2010 to that in 2014?
Make the answer very short. 0.75. What is the ratio of the ATMs(per 100,000 adults) in Argentina in 2011 to that in 2012?
Keep it short and to the point. 0.93. What is the ratio of the ATMs(per 100,000 adults) in Moldova in 2011 to that in 2012?
Your answer should be compact. 0.92. What is the ratio of the ATMs(per 100,000 adults) in Nicaragua in 2011 to that in 2012?
Your answer should be compact. 0.84. What is the ratio of the ATMs(per 100,000 adults) in Argentina in 2011 to that in 2013?
Keep it short and to the point. 0.84. What is the ratio of the ATMs(per 100,000 adults) of Marshall Islands in 2011 to that in 2013?
Offer a terse response. 1. What is the ratio of the ATMs(per 100,000 adults) of Moldova in 2011 to that in 2013?
Your answer should be compact. 0.85. What is the ratio of the ATMs(per 100,000 adults) of Nicaragua in 2011 to that in 2013?
Ensure brevity in your answer.  0.67. What is the ratio of the ATMs(per 100,000 adults) in Argentina in 2011 to that in 2014?
Offer a terse response. 0.81. What is the ratio of the ATMs(per 100,000 adults) of Marshall Islands in 2011 to that in 2014?
Keep it short and to the point. 1.01. What is the ratio of the ATMs(per 100,000 adults) of Moldova in 2011 to that in 2014?
Keep it short and to the point. 0.78. What is the ratio of the ATMs(per 100,000 adults) in Nicaragua in 2011 to that in 2014?
Offer a terse response. 0.85. What is the ratio of the ATMs(per 100,000 adults) in Argentina in 2012 to that in 2013?
Offer a very short reply. 0.91. What is the ratio of the ATMs(per 100,000 adults) of Marshall Islands in 2012 to that in 2013?
Offer a very short reply. 1. What is the ratio of the ATMs(per 100,000 adults) of Moldova in 2012 to that in 2013?
Provide a succinct answer. 0.92. What is the ratio of the ATMs(per 100,000 adults) of Nicaragua in 2012 to that in 2013?
Ensure brevity in your answer.  0.8. What is the ratio of the ATMs(per 100,000 adults) in Argentina in 2012 to that in 2014?
Your answer should be compact. 0.86. What is the ratio of the ATMs(per 100,000 adults) in Marshall Islands in 2012 to that in 2014?
Keep it short and to the point. 1. What is the ratio of the ATMs(per 100,000 adults) of Moldova in 2012 to that in 2014?
Make the answer very short. 0.85. What is the ratio of the ATMs(per 100,000 adults) of Nicaragua in 2012 to that in 2014?
Ensure brevity in your answer.  1.02. What is the ratio of the ATMs(per 100,000 adults) of Argentina in 2013 to that in 2014?
Offer a terse response. 0.95. What is the ratio of the ATMs(per 100,000 adults) in Marshall Islands in 2013 to that in 2014?
Provide a succinct answer. 1. What is the ratio of the ATMs(per 100,000 adults) of Moldova in 2013 to that in 2014?
Offer a terse response. 0.93. What is the ratio of the ATMs(per 100,000 adults) of Nicaragua in 2013 to that in 2014?
Give a very brief answer. 1.27. What is the difference between the highest and the second highest ATMs(per 100,000 adults) of Argentina?
Offer a very short reply. 2.7. What is the difference between the highest and the second highest ATMs(per 100,000 adults) of Marshall Islands?
Give a very brief answer. 0.01. What is the difference between the highest and the second highest ATMs(per 100,000 adults) in Moldova?
Ensure brevity in your answer.  2.65. What is the difference between the highest and the second highest ATMs(per 100,000 adults) in Nicaragua?
Make the answer very short. 2.92. What is the difference between the highest and the lowest ATMs(per 100,000 adults) in Argentina?
Provide a succinct answer. 26.31. What is the difference between the highest and the lowest ATMs(per 100,000 adults) of Marshall Islands?
Your answer should be compact. 2.97. What is the difference between the highest and the lowest ATMs(per 100,000 adults) in Moldova?
Make the answer very short. 16.84. What is the difference between the highest and the lowest ATMs(per 100,000 adults) in Nicaragua?
Your response must be concise. 6.53. 